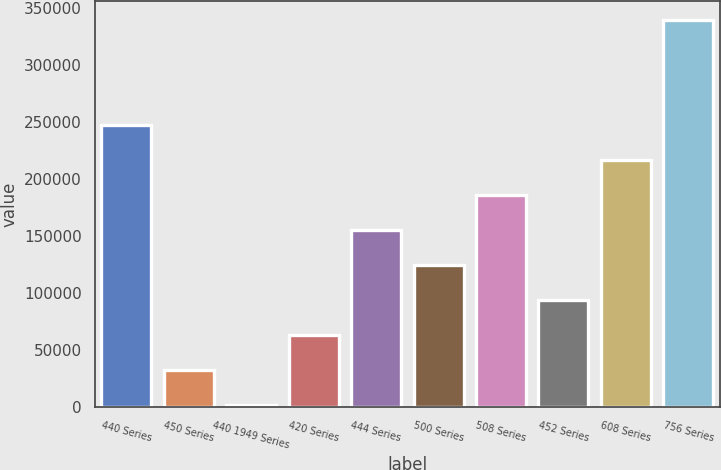Convert chart. <chart><loc_0><loc_0><loc_500><loc_500><bar_chart><fcel>440 Series<fcel>450 Series<fcel>440 1949 Series<fcel>420 Series<fcel>444 Series<fcel>500 Series<fcel>508 Series<fcel>452 Series<fcel>608 Series<fcel>756 Series<nl><fcel>247395<fcel>32372.5<fcel>1655<fcel>63090<fcel>155242<fcel>124525<fcel>185960<fcel>93807.5<fcel>216678<fcel>339548<nl></chart> 